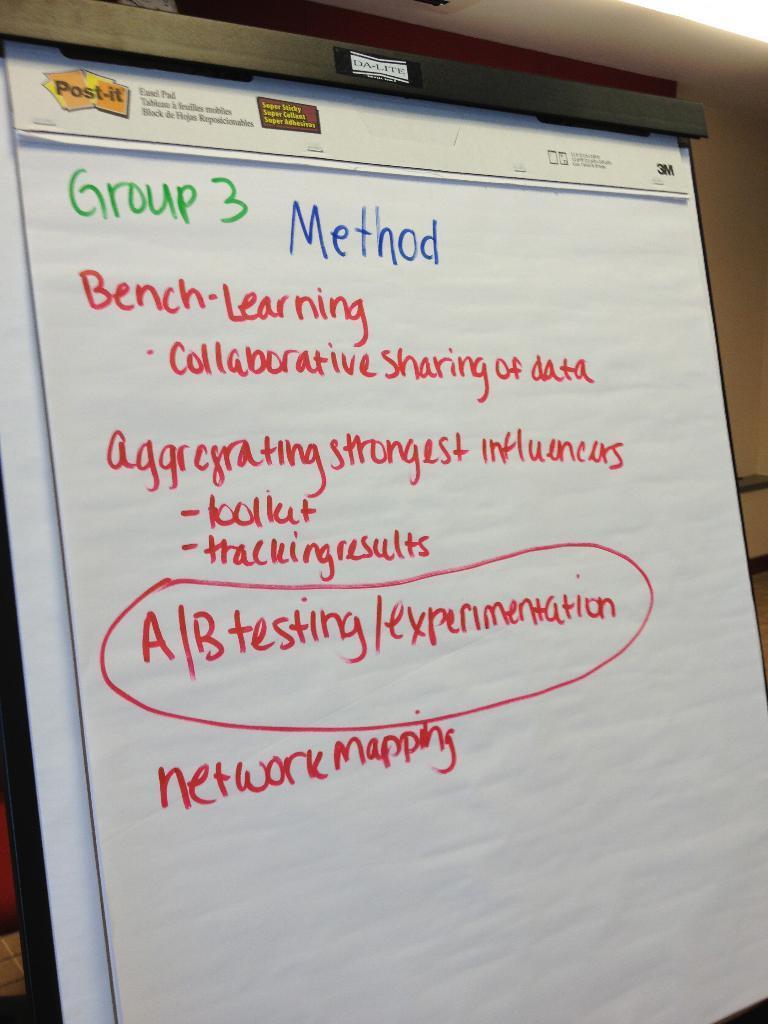How would you summarize this image in a sentence or two? In the foreground of this image, there is a board on which there is some text. In the background, there is a wall. 